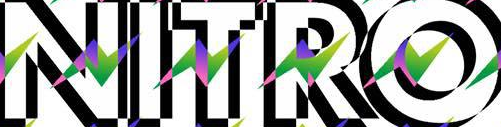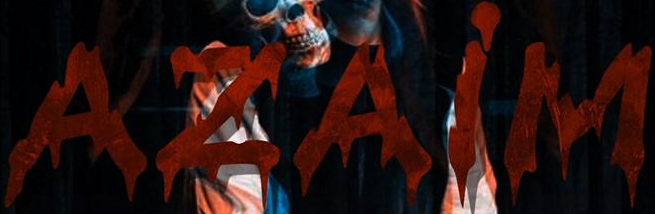What words can you see in these images in sequence, separated by a semicolon? NITRO; AZAiM 